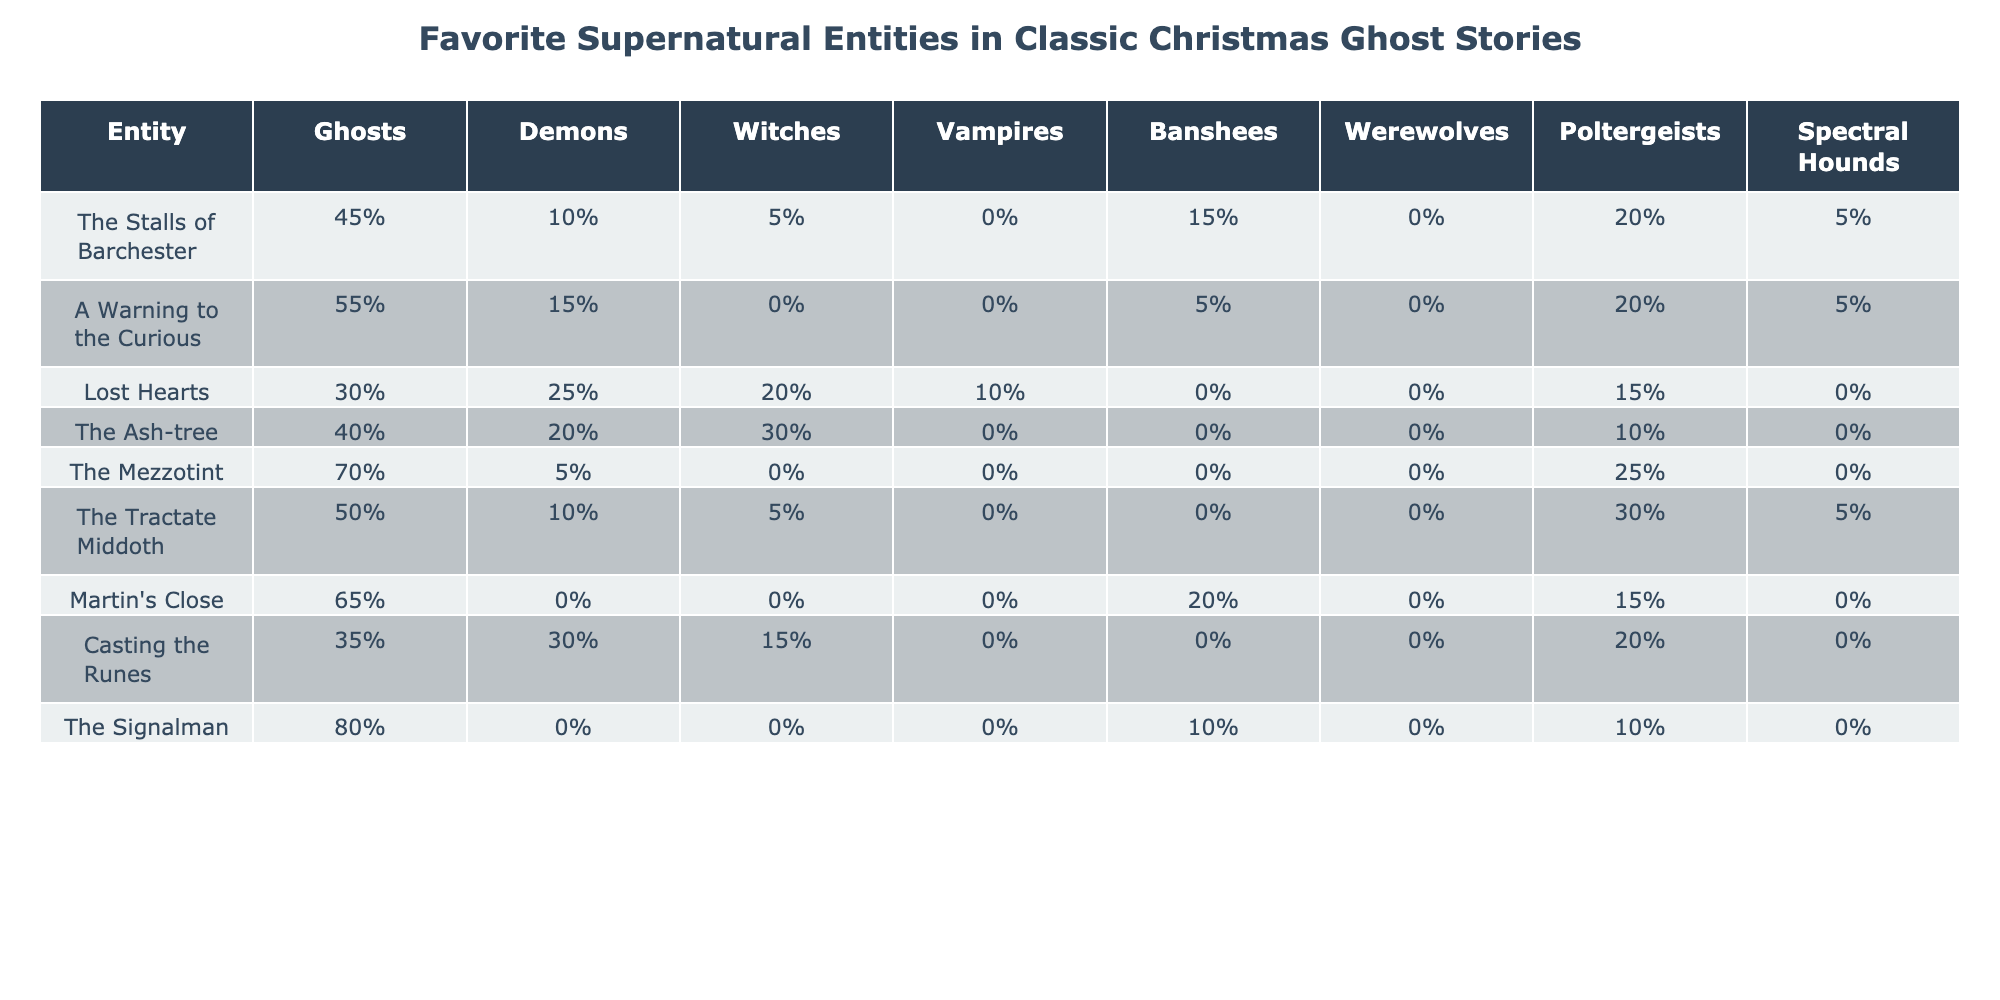What percentage of respondents favor "The Signalman" as their ghost story? The table shows that the percentage for "The Signalman" is 80% under the Ghosts column.
Answer: 80% Which supernatural entity is most commonly favored in "The Mezzotint"? According to the table, "The Mezzotint" shows the highest percentage contribution for Ghosts at 70%.
Answer: Ghosts How does the popularity of Witches compare in "Lost Hearts" and "Casting the Runes"? "Lost Hearts" has 20% favoring Witches, while "Casting the Runes" has 15%. The comparison shows that Witches are more popular in "Lost Hearts" by a difference of 5%.
Answer: 5% Which entity received no favor in the category of Vampires across all surveyed stories? Upon reviewing the data, "The Stalls of Barchester", "A Warning to the Curious", "The Mezzotint", "The Tractate Middoth", "Martin's Close", and "The Ash-tree" all show 0% for Vampires.
Answer: True Calculate the total percentage of "Poltergeists" favored across all stories. Summing the percentages from the Poltergeists column gives: 5% + 5% + 0% + 0% + 0% + 0% + 0% + 20% + 30% = 60%. Thus, the total percentage for Poltergeists is 60%.
Answer: 60% Which ghost story has the highest percentage for Banshees? The table indicates "The Stalls of Barchester" has the highest percentage of Banshees at 15%.
Answer: 15% What is the average percentage of Demons across all ghost stories? The percentages for Demons are 10%, 15%, 25%, 20%, 5%, 10%, 0%, 30%, 0%. Adding these gives 115% and dividing by 9 (the number of stories) results in approximately 12.78%.
Answer: Approximately 12.78% To summarize the percentages for Ghosts, what is the total percentage when considering only the top three stories with the highest percentages? The top three stories with the highest percentages for Ghosts are "The Signalman" (80%), "The Mezzotint" (70%), and "A Warning to the Curious" (55%). Adding these gives: 80% + 70% + 55% = 205%.
Answer: 205% Which supernatural entity is least favored in "Martin's Close"? Analyzing the data for "Martin's Close", the least favored entity is Demons, which received 0%.
Answer: Demons What is the percentage difference for Werewolves between "Lost Hearts" and "The Ash-tree"? "Lost Hearts" shows 0% for Werewolves, while "The Ash-tree" also shows 0%. Therefore, the difference is 0%.
Answer: 0% 